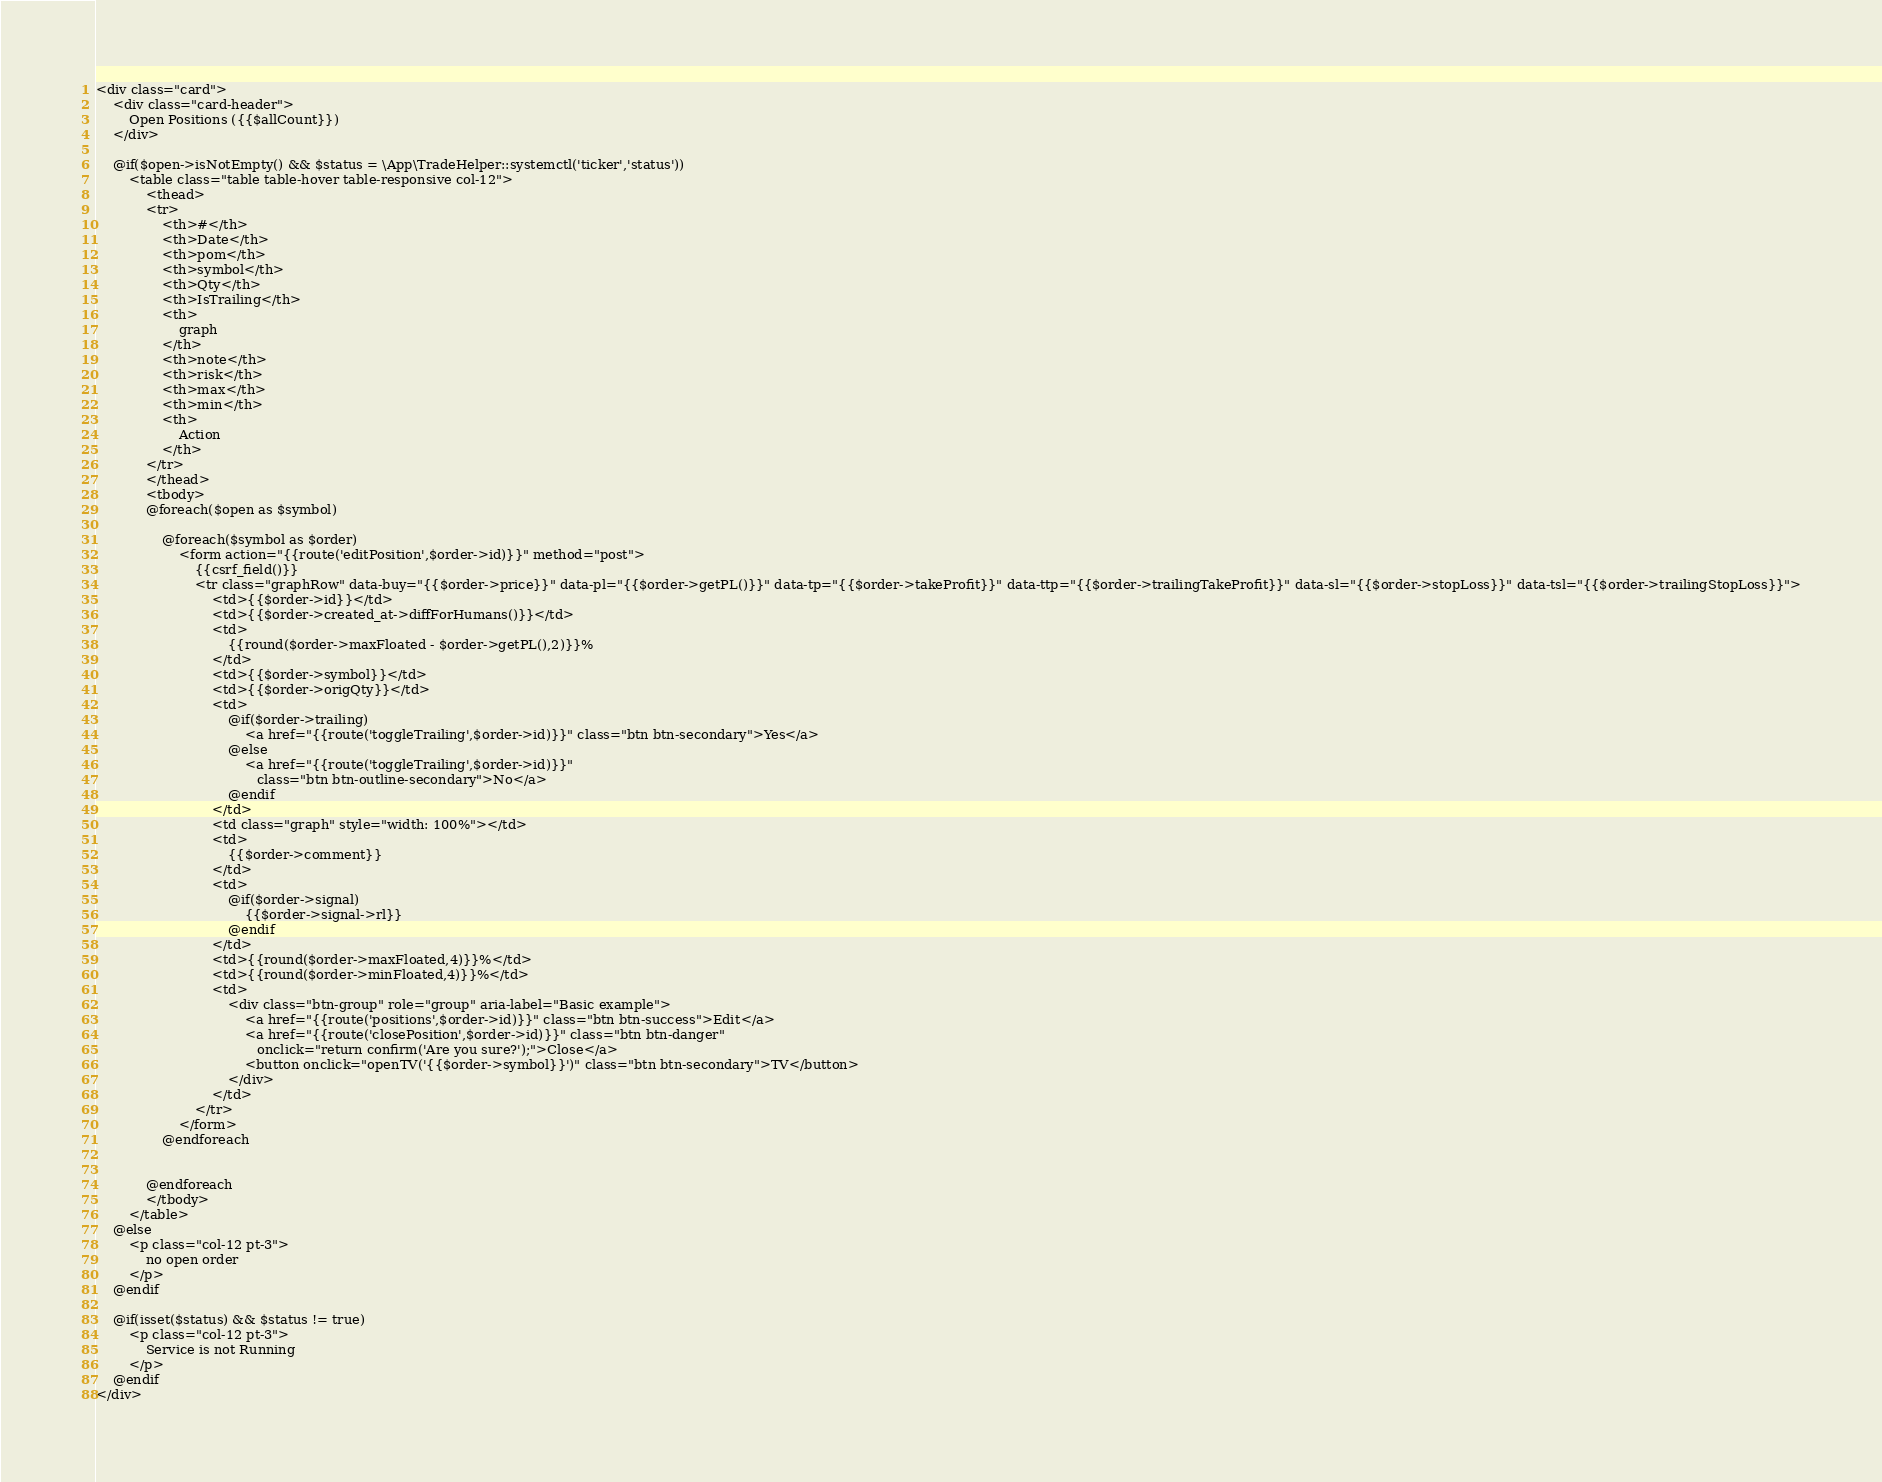Convert code to text. <code><loc_0><loc_0><loc_500><loc_500><_PHP_><div class="card">
    <div class="card-header">
        Open Positions ({{$allCount}})
    </div>

    @if($open->isNotEmpty() && $status = \App\TradeHelper::systemctl('ticker','status'))
        <table class="table table-hover table-responsive col-12">
            <thead>
            <tr>
                <th>#</th>
                <th>Date</th>
                <th>pom</th>
                <th>symbol</th>
                <th>Qty</th>
                <th>IsTrailing</th>
                <th>
                    graph
                </th>
                <th>note</th>
                <th>risk</th>
                <th>max</th>
                <th>min</th>
                <th>
                    Action
                </th>
            </tr>
            </thead>
            <tbody>
            @foreach($open as $symbol)

                @foreach($symbol as $order)
                    <form action="{{route('editPosition',$order->id)}}" method="post">
                        {{csrf_field()}}
                        <tr class="graphRow" data-buy="{{$order->price}}" data-pl="{{$order->getPL()}}" data-tp="{{$order->takeProfit}}" data-ttp="{{$order->trailingTakeProfit}}" data-sl="{{$order->stopLoss}}" data-tsl="{{$order->trailingStopLoss}}">
                            <td>{{$order->id}}</td>
                            <td>{{$order->created_at->diffForHumans()}}</td>
                            <td>
                                {{round($order->maxFloated - $order->getPL(),2)}}%
                            </td>
                            <td>{{$order->symbol}}</td>
                            <td>{{$order->origQty}}</td>
                            <td>
                                @if($order->trailing)
                                    <a href="{{route('toggleTrailing',$order->id)}}" class="btn btn-secondary">Yes</a>
                                @else
                                    <a href="{{route('toggleTrailing',$order->id)}}"
                                       class="btn btn-outline-secondary">No</a>
                                @endif
                            </td>
                            <td class="graph" style="width: 100%"></td>
                            <td>
                                {{$order->comment}}
                            </td>
                            <td>
                                @if($order->signal)
                                    {{$order->signal->rl}}
                                @endif
                            </td>
                            <td>{{round($order->maxFloated,4)}}%</td>
                            <td>{{round($order->minFloated,4)}}%</td>
                            <td>
                                <div class="btn-group" role="group" aria-label="Basic example">
                                    <a href="{{route('positions',$order->id)}}" class="btn btn-success">Edit</a>
                                    <a href="{{route('closePosition',$order->id)}}" class="btn btn-danger"
                                       onclick="return confirm('Are you sure?');">Close</a>
                                    <button onclick="openTV('{{$order->symbol}}')" class="btn btn-secondary">TV</button>
                                </div>
                            </td>
                        </tr>
                    </form>
                @endforeach


            @endforeach
            </tbody>
        </table>
    @else
        <p class="col-12 pt-3">
            no open order
        </p>
    @endif

    @if(isset($status) && $status != true)
        <p class="col-12 pt-3">
            Service is not Running
        </p>
    @endif
</div></code> 